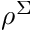Convert formula to latex. <formula><loc_0><loc_0><loc_500><loc_500>\rho ^ { \Sigma }</formula> 